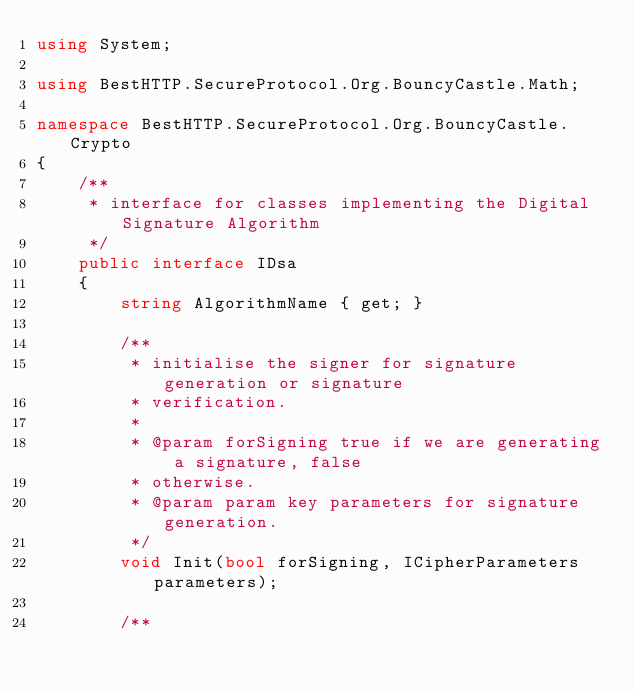<code> <loc_0><loc_0><loc_500><loc_500><_C#_>using System;

using BestHTTP.SecureProtocol.Org.BouncyCastle.Math;

namespace BestHTTP.SecureProtocol.Org.BouncyCastle.Crypto
{
    /**
     * interface for classes implementing the Digital Signature Algorithm
     */
    public interface IDsa
    {
		string AlgorithmName { get; }

		/**
         * initialise the signer for signature generation or signature
         * verification.
         *
         * @param forSigning true if we are generating a signature, false
         * otherwise.
         * @param param key parameters for signature generation.
         */
        void Init(bool forSigning, ICipherParameters parameters);

        /**</code> 